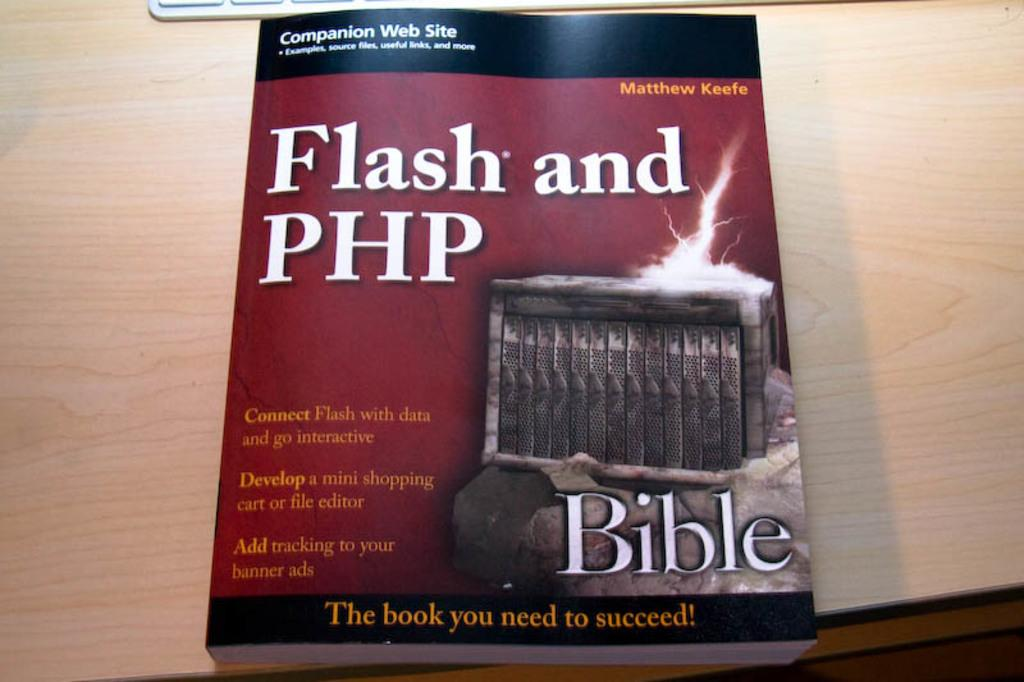<image>
Render a clear and concise summary of the photo. the word bible is on the front of the book 